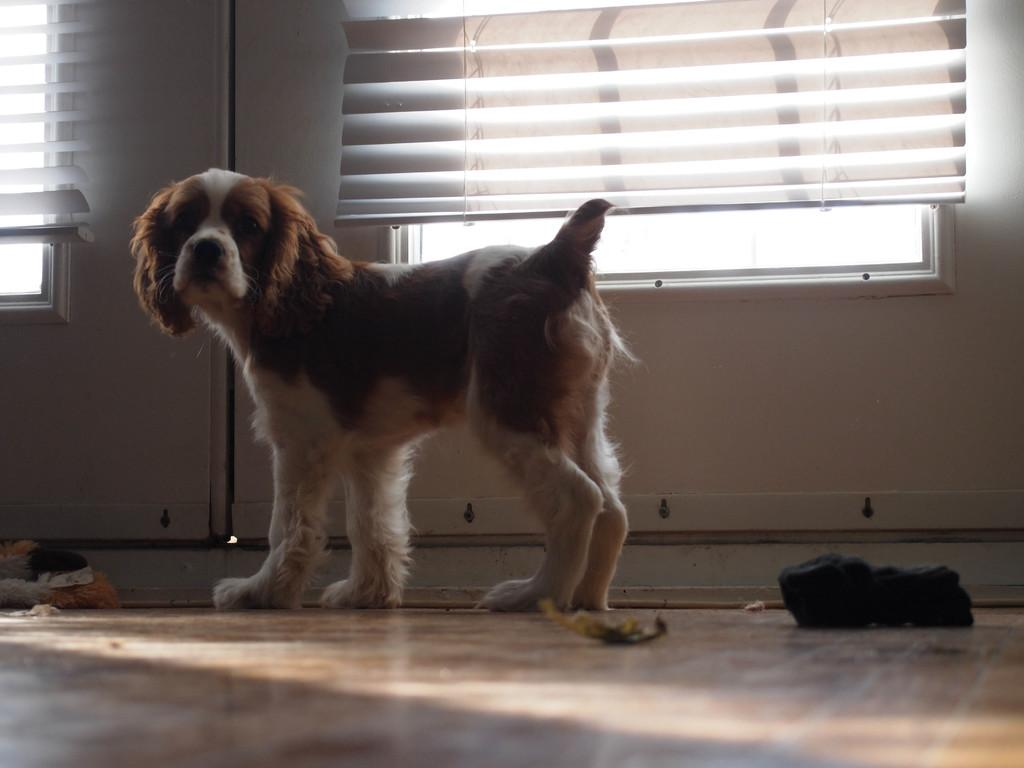What type of animal is in the image? There is a dog in the image. Can you describe the dog's appearance? The dog is brown and cream in color. What can be seen in the background of the image? There are two windows in the background of the image. What color is the wall in the image? The wall is white in color. What type of glue is being used to hold the basket in the image? There is no basket or glue present in the image; it features a dog and a white wall with two windows. 